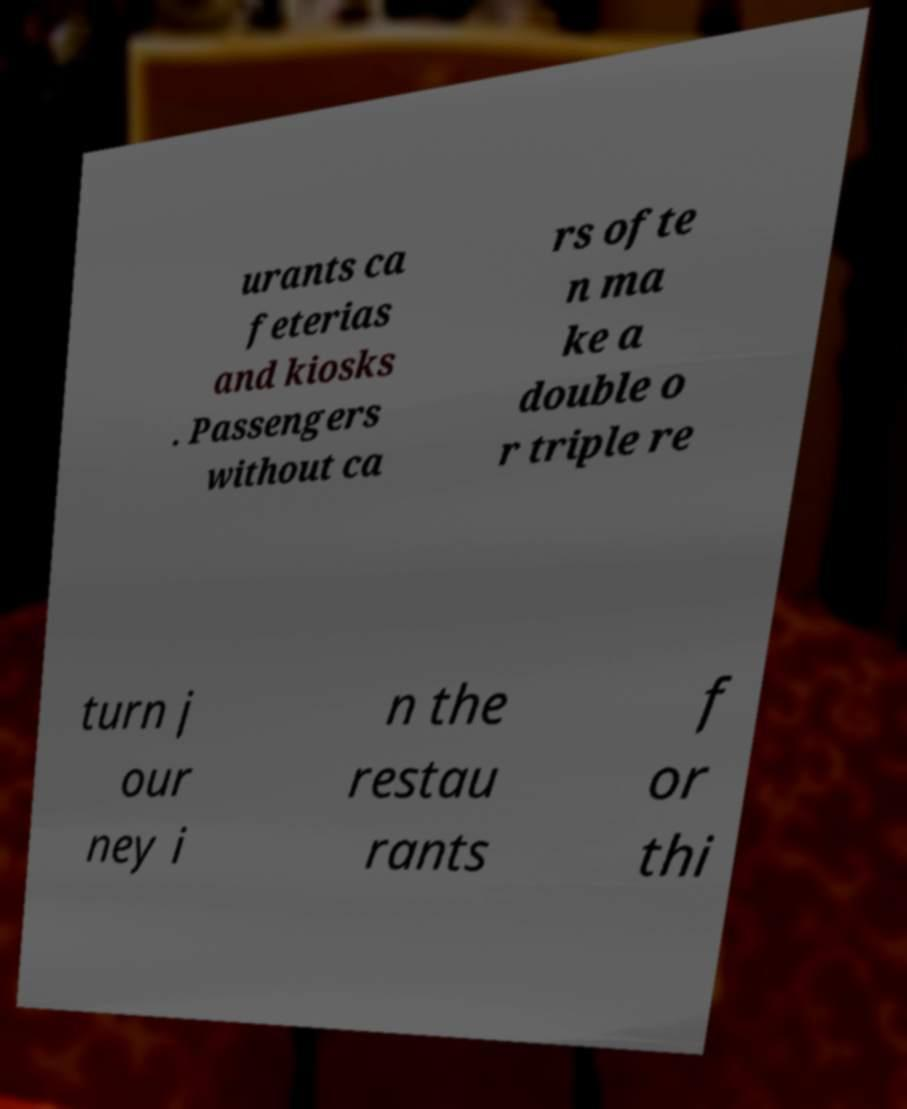Please read and relay the text visible in this image. What does it say? urants ca feterias and kiosks . Passengers without ca rs ofte n ma ke a double o r triple re turn j our ney i n the restau rants f or thi 